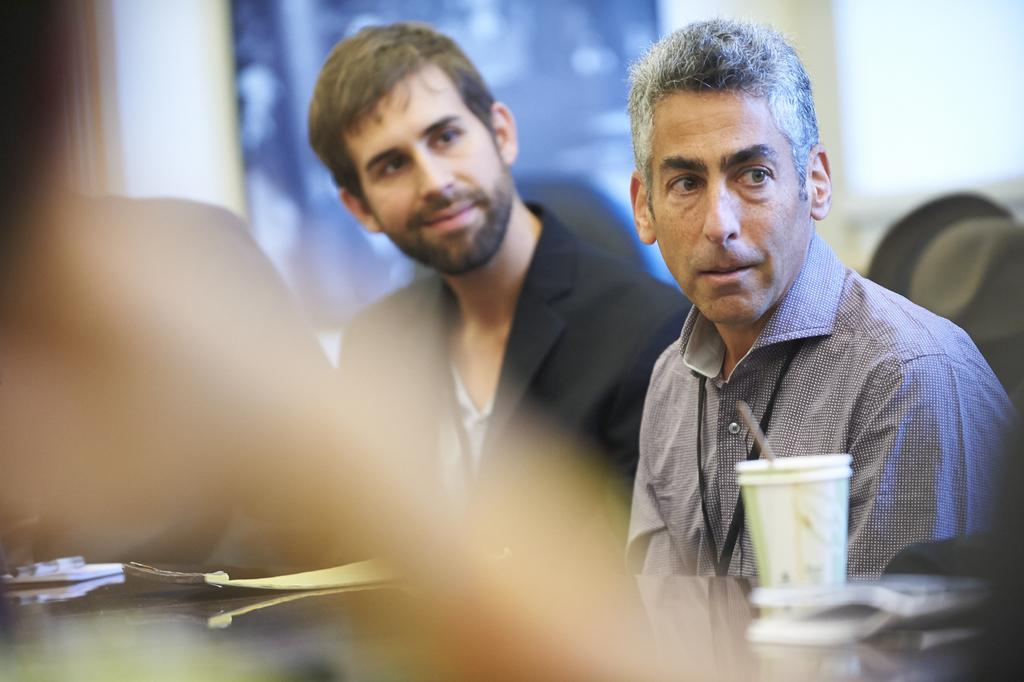How many people are sitting in the image? There are two people sitting in the center of the image. What is placed in front of the people? There is a glass and other objects in front of the people. Can you describe the background of the image? The background of the image is blurred. What type of riddle is being solved by the people in the image? There is no riddle being solved in the image; it only shows two people sitting with a glass and other objects in front of them. What kind of metal is used to make the plantation in the image? There is no mention of a plantation or metal in the image; it only features two people sitting with a glass and other objects in front of them. 